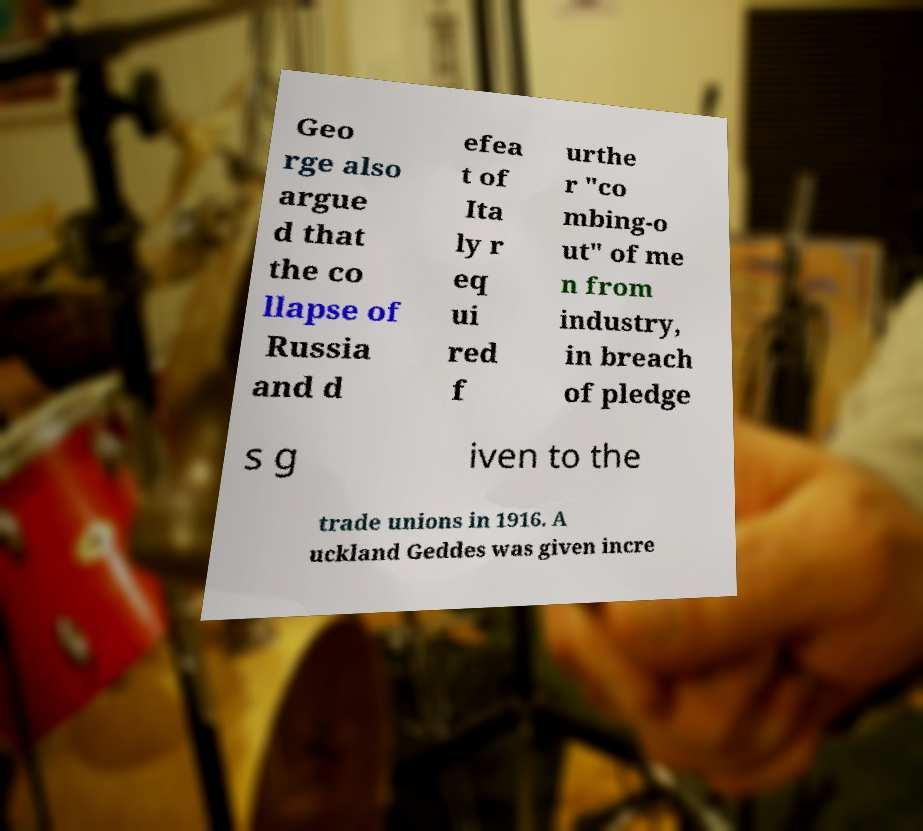I need the written content from this picture converted into text. Can you do that? Geo rge also argue d that the co llapse of Russia and d efea t of Ita ly r eq ui red f urthe r "co mbing-o ut" of me n from industry, in breach of pledge s g iven to the trade unions in 1916. A uckland Geddes was given incre 